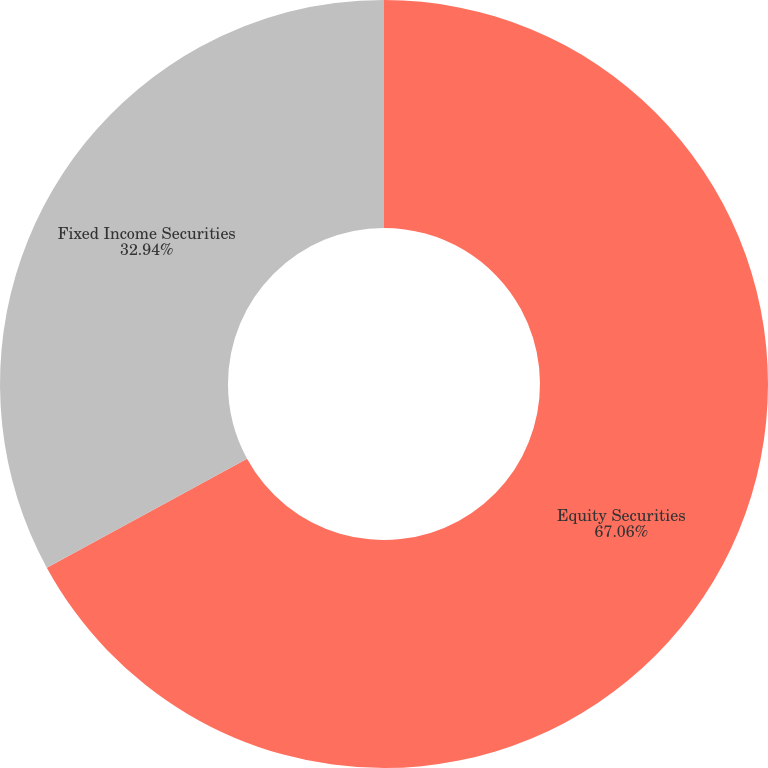Convert chart. <chart><loc_0><loc_0><loc_500><loc_500><pie_chart><fcel>Equity Securities<fcel>Fixed Income Securities<nl><fcel>67.06%<fcel>32.94%<nl></chart> 